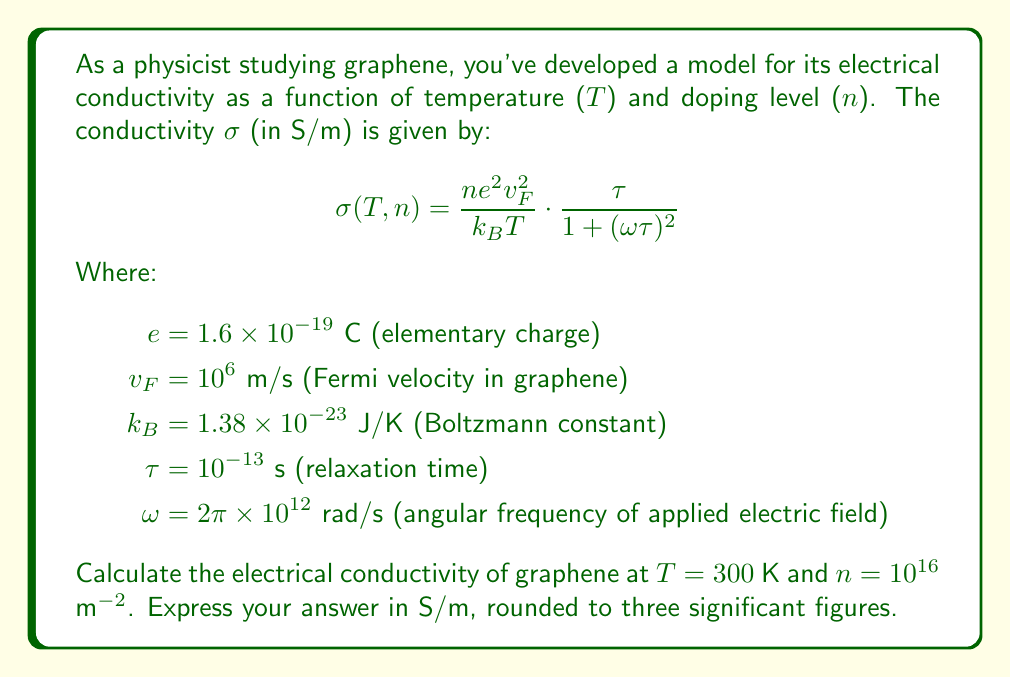Solve this math problem. To solve this problem, we'll follow these steps:

1) First, let's substitute the given values into the equation:

   $$σ(300,10^{16}) = \frac{(10^{16})(1.6 \times 10^{-19})^2(10^6)^2}{(1.38 \times 10^{-23})(300)} \cdot \frac{10^{-13}}{1 + (2π \times 10^{12} \times 10^{-13})^2}$$

2) Let's calculate the numerator and denominator of the first fraction:
   
   Numerator: $(10^{16})(1.6 \times 10^{-19})^2(10^6)^2 = 2.56 \times 10^{-10}$
   Denominator: $(1.38 \times 10^{-23})(300) = 4.14 \times 10^{-21}$

3) Now, let's calculate the second fraction:
   
   $ωτ = (2π \times 10^{12})(10^{-13}) = 2π \times 10^{-1} ≈ 0.6283$
   
   Denominator: $1 + (0.6283)^2 ≈ 1.3947$

4) Putting it all together:

   $$σ = \frac{2.56 \times 10^{-10}}{4.14 \times 10^{-21}} \cdot \frac{10^{-13}}{1.3947}$$

5) Simplify:
   
   $$σ = (6.18 \times 10^{10}) \cdot (7.17 \times 10^{-14}) = 4.43 \times 10^{-3}$$

6) Therefore, the conductivity is approximately 4.43 × 10^(-3) S/m.
Answer: 4.43 × 10^(-3) S/m 